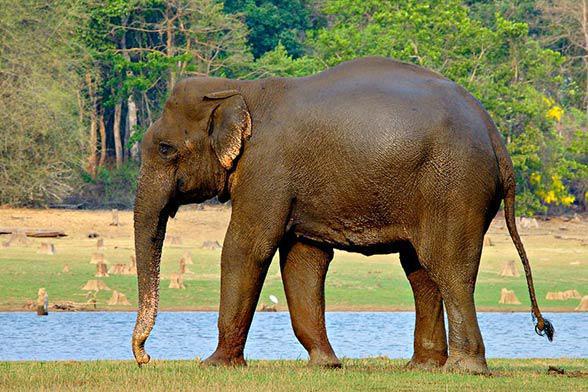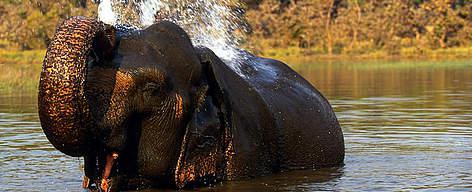The first image is the image on the left, the second image is the image on the right. Considering the images on both sides, is "In the image to the right, the elephant is right before a tree." valid? Answer yes or no. No. 